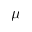<formula> <loc_0><loc_0><loc_500><loc_500>\mu</formula> 